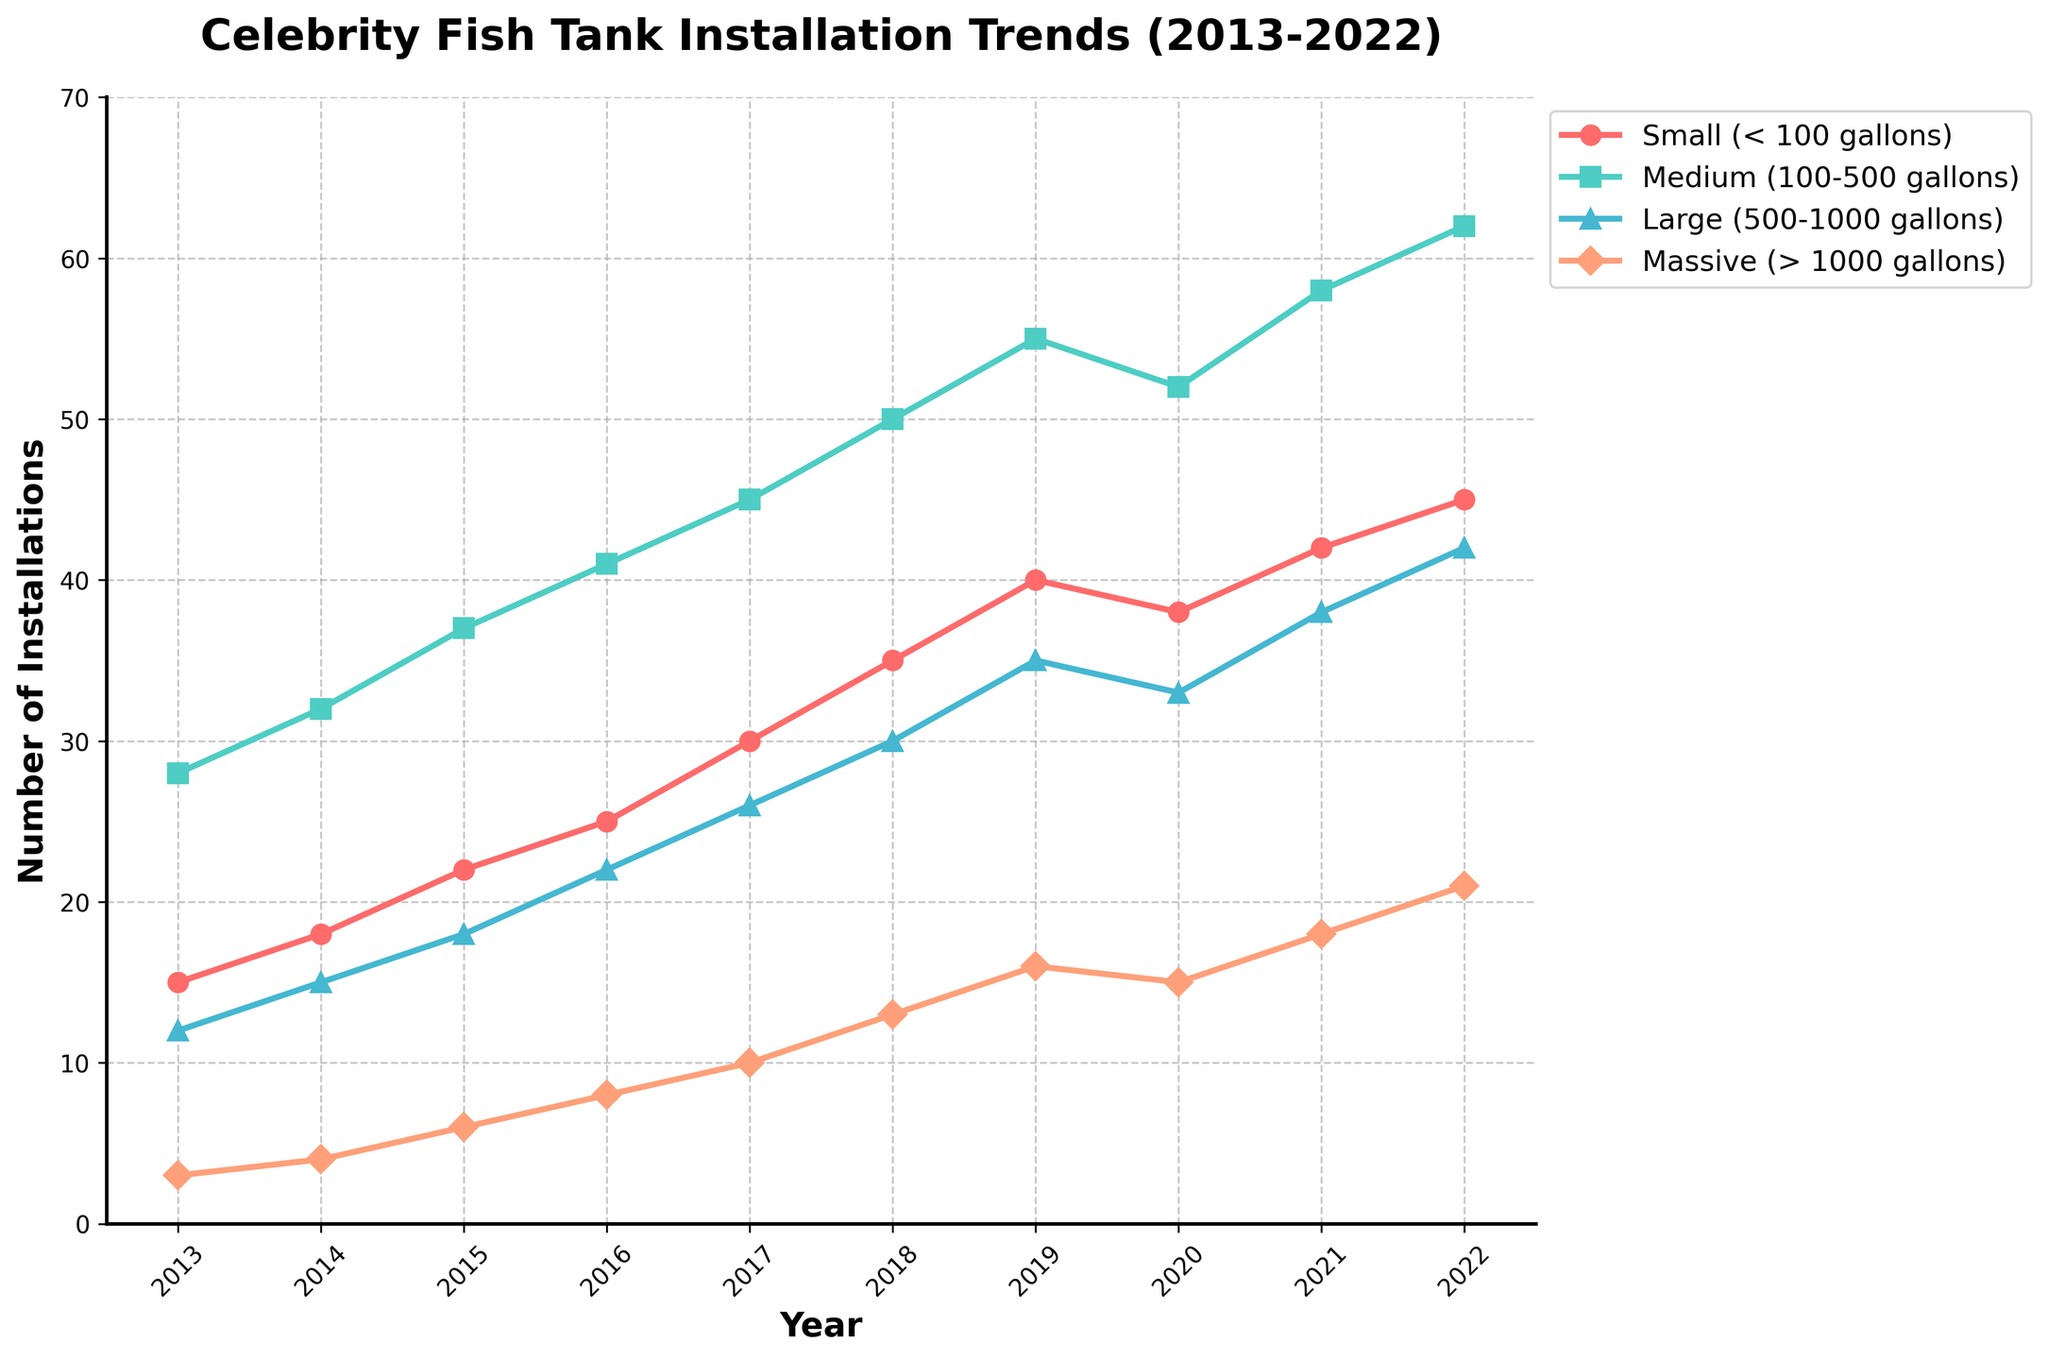What is the overall trend for small fish tank installations from 2013 to 2022? Observe that the line for "Small (< 100 gallons)" consistently rises from year to year, indicating a gradual increase.
Answer: Increasing Which size category experienced the highest increase in installations between 2013 and 2022? Calculate the difference between 2022 and 2013 for each category: Small (45-15=30), Medium (62-28=34), Large (42-12=30), Massive (21-3=18). The Medium category shows the highest increase.
Answer: Medium (100-500 gallons) By how much did massive fish tank installations increase from 2013 to 2022? Subtract the number of installations in 2013 from that in 2022 for the "Massive (> 1000 gallons)" category: 21 - 3 = 18.
Answer: 18 Which year did medium fish tank installations reach 50? Look at the data points for "Medium (100-500 gallons)" and find the year corresponding to 50 installations, which is 2018.
Answer: 2018 By what percentage did small fish tank installations increase from 2013 to 2022? Calculate the percentage increase as (45-15)/15 * 100 = 200%.
Answer: 200% What is the ratio of medium to small fish tank installations in 2022? The values for 2022 are 62 (medium) and 45 (small). The ratio is 62:45, which simplifies to approximately 1.38:1.
Answer: 1.38:1 During which year did large fish tank installations first surpass 30? Look at the annual data for "Large (500-1000 gallons)" and see when it goes above 30, which first occurs in 2018.
Answer: 2018 Which size category had the fewest installations in 2020? The values for 2020 are Small (38), Medium (52), Large (33), Massive (15). The lowest number is 15 in the Massive category.
Answer: Massive (> 1000 gallons) By what amount did the number of large tank installations decrease from 2019 to 2020? Subtract the number for 2020 from that for 2019 in the "Large (500-1000 gallons)" category: 35 - 33 = 2.
Answer: 2 